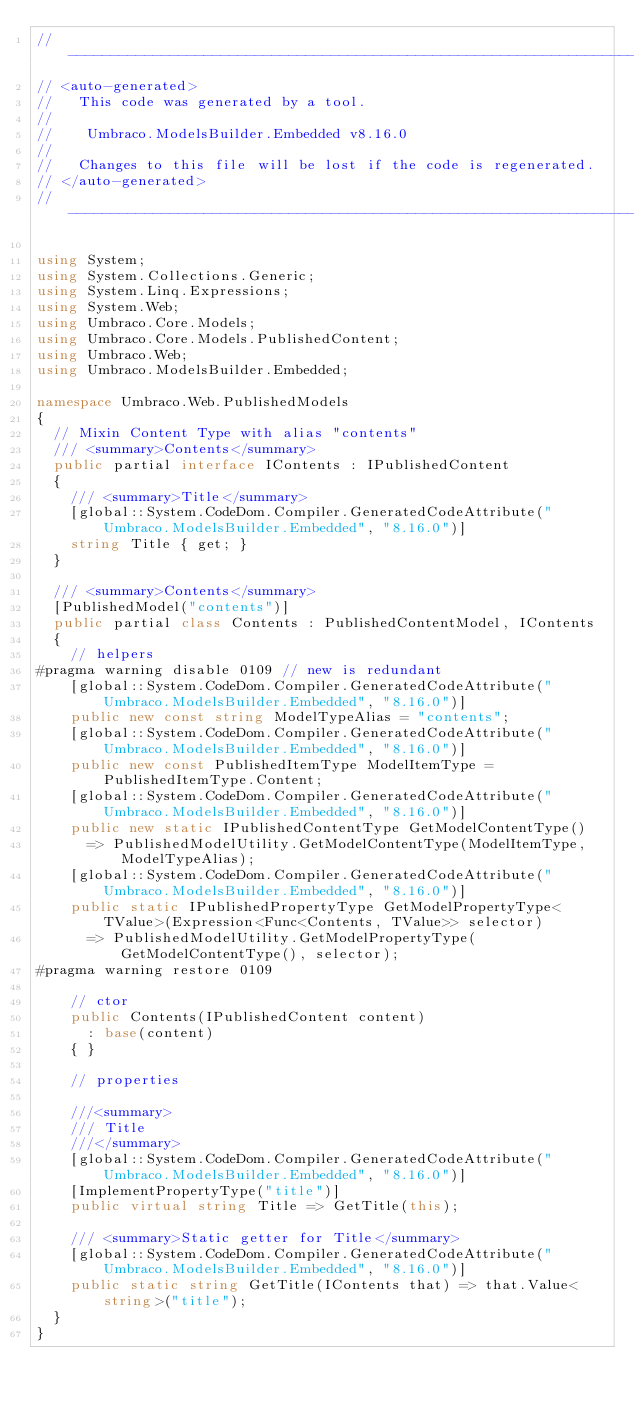<code> <loc_0><loc_0><loc_500><loc_500><_C#_>//------------------------------------------------------------------------------
// <auto-generated>
//   This code was generated by a tool.
//
//    Umbraco.ModelsBuilder.Embedded v8.16.0
//
//   Changes to this file will be lost if the code is regenerated.
// </auto-generated>
//------------------------------------------------------------------------------

using System;
using System.Collections.Generic;
using System.Linq.Expressions;
using System.Web;
using Umbraco.Core.Models;
using Umbraco.Core.Models.PublishedContent;
using Umbraco.Web;
using Umbraco.ModelsBuilder.Embedded;

namespace Umbraco.Web.PublishedModels
{
	// Mixin Content Type with alias "contents"
	/// <summary>Contents</summary>
	public partial interface IContents : IPublishedContent
	{
		/// <summary>Title</summary>
		[global::System.CodeDom.Compiler.GeneratedCodeAttribute("Umbraco.ModelsBuilder.Embedded", "8.16.0")]
		string Title { get; }
	}

	/// <summary>Contents</summary>
	[PublishedModel("contents")]
	public partial class Contents : PublishedContentModel, IContents
	{
		// helpers
#pragma warning disable 0109 // new is redundant
		[global::System.CodeDom.Compiler.GeneratedCodeAttribute("Umbraco.ModelsBuilder.Embedded", "8.16.0")]
		public new const string ModelTypeAlias = "contents";
		[global::System.CodeDom.Compiler.GeneratedCodeAttribute("Umbraco.ModelsBuilder.Embedded", "8.16.0")]
		public new const PublishedItemType ModelItemType = PublishedItemType.Content;
		[global::System.CodeDom.Compiler.GeneratedCodeAttribute("Umbraco.ModelsBuilder.Embedded", "8.16.0")]
		public new static IPublishedContentType GetModelContentType()
			=> PublishedModelUtility.GetModelContentType(ModelItemType, ModelTypeAlias);
		[global::System.CodeDom.Compiler.GeneratedCodeAttribute("Umbraco.ModelsBuilder.Embedded", "8.16.0")]
		public static IPublishedPropertyType GetModelPropertyType<TValue>(Expression<Func<Contents, TValue>> selector)
			=> PublishedModelUtility.GetModelPropertyType(GetModelContentType(), selector);
#pragma warning restore 0109

		// ctor
		public Contents(IPublishedContent content)
			: base(content)
		{ }

		// properties

		///<summary>
		/// Title
		///</summary>
		[global::System.CodeDom.Compiler.GeneratedCodeAttribute("Umbraco.ModelsBuilder.Embedded", "8.16.0")]
		[ImplementPropertyType("title")]
		public virtual string Title => GetTitle(this);

		/// <summary>Static getter for Title</summary>
		[global::System.CodeDom.Compiler.GeneratedCodeAttribute("Umbraco.ModelsBuilder.Embedded", "8.16.0")]
		public static string GetTitle(IContents that) => that.Value<string>("title");
	}
}
</code> 